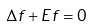Convert formula to latex. <formula><loc_0><loc_0><loc_500><loc_500>\Delta f + E f = 0</formula> 